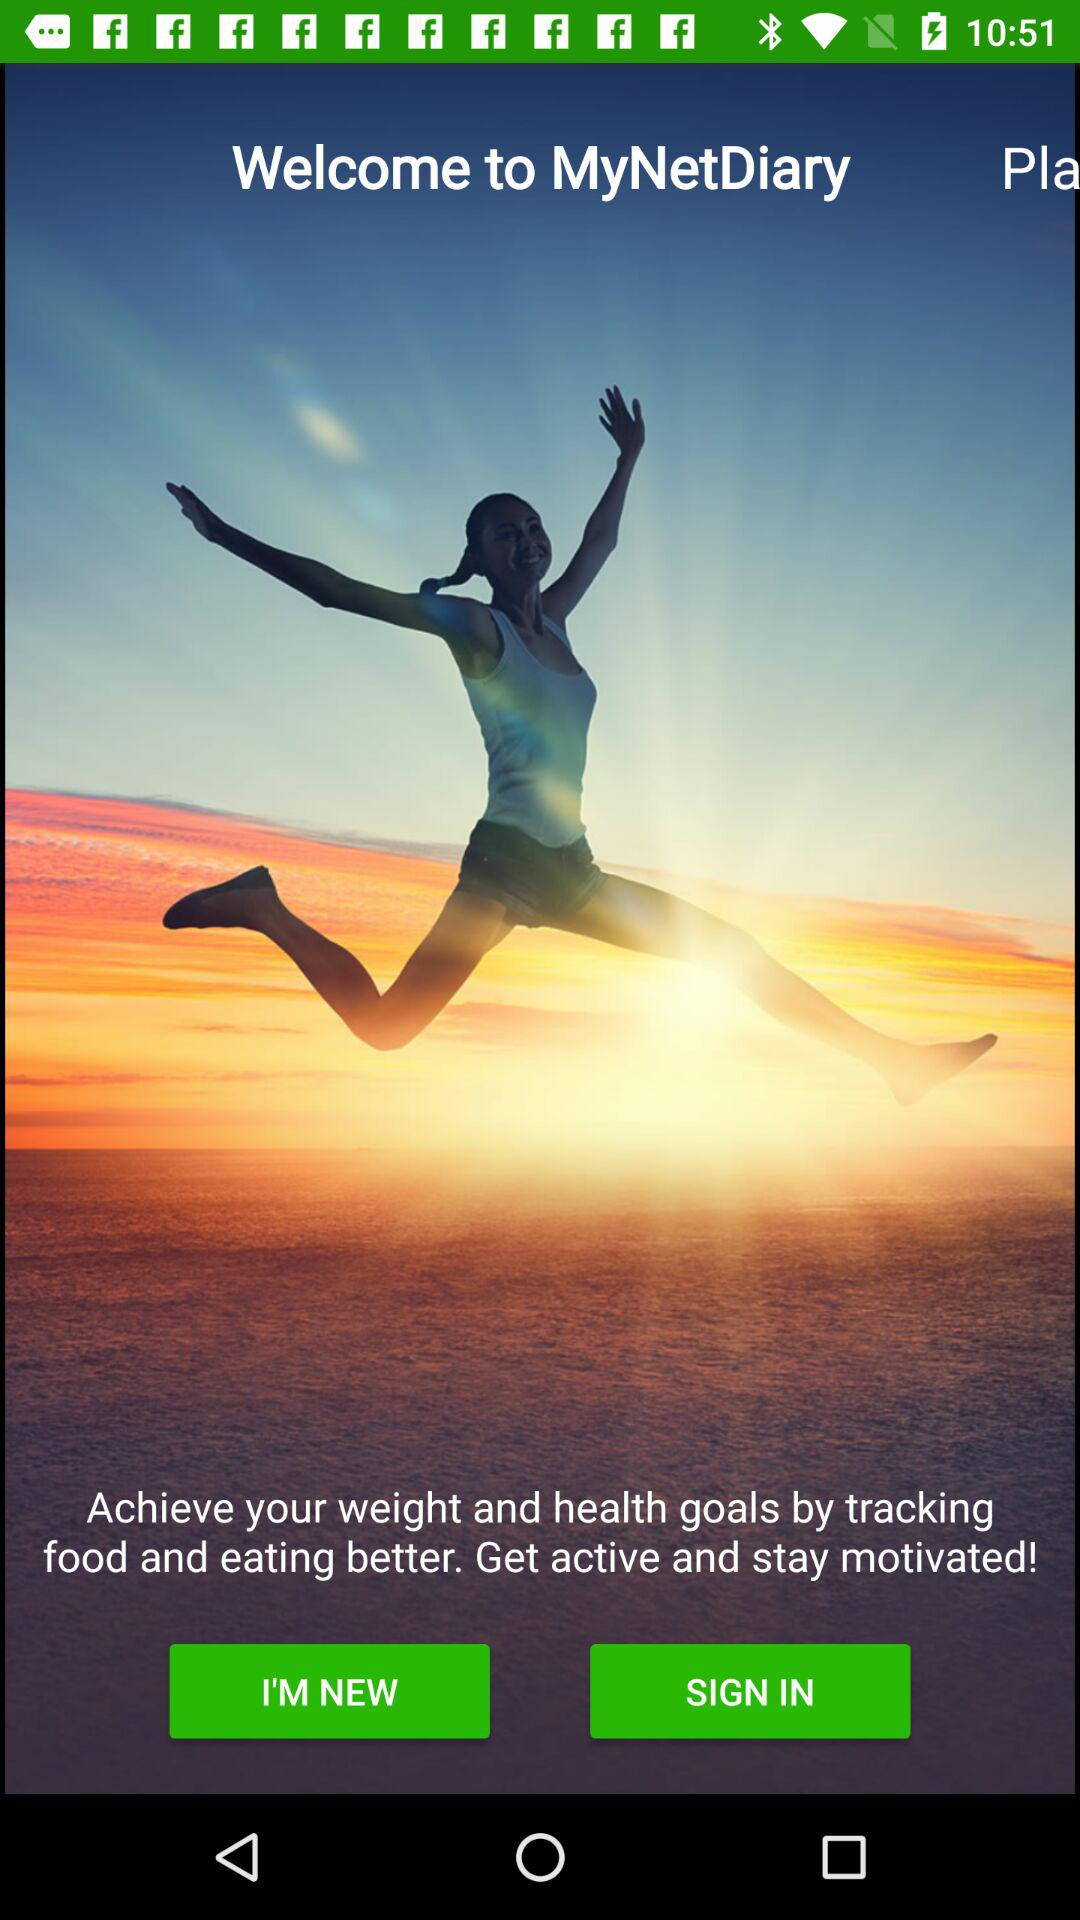What is the application name? The application name is "MyNetDiary". 